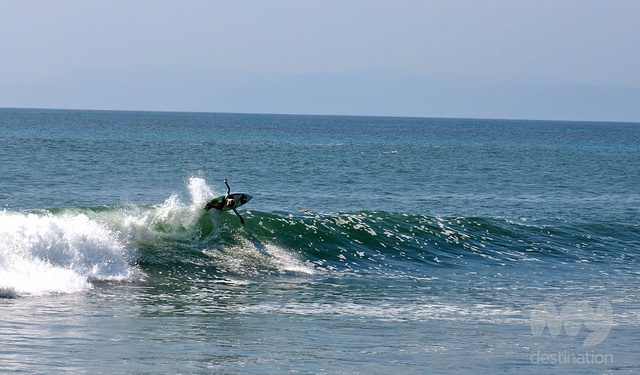Describe the objects in this image and their specific colors. I can see people in lavender, black, gray, navy, and darkgray tones and surfboard in lavender, black, blue, darkblue, and darkgreen tones in this image. 